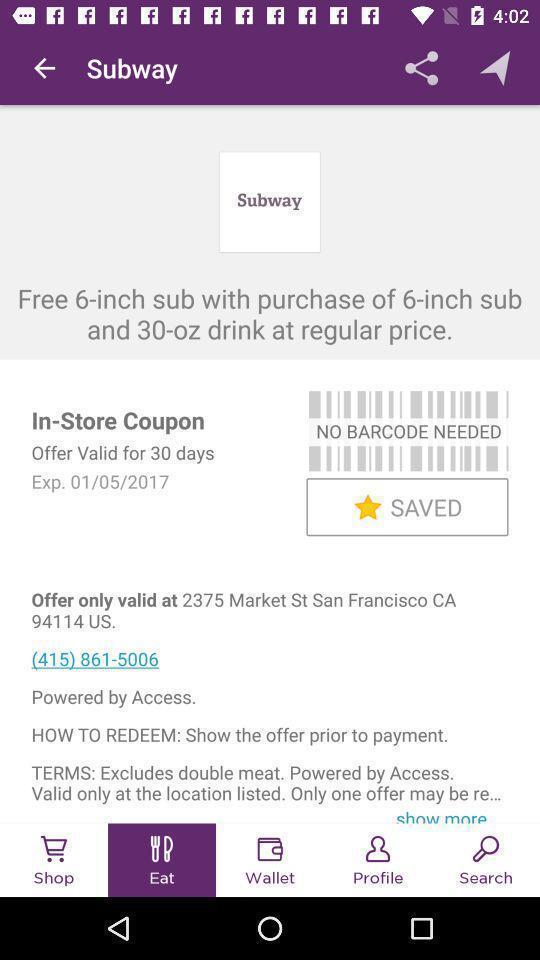Tell me about the visual elements in this screen capture. Page showing coupan details on an app. 